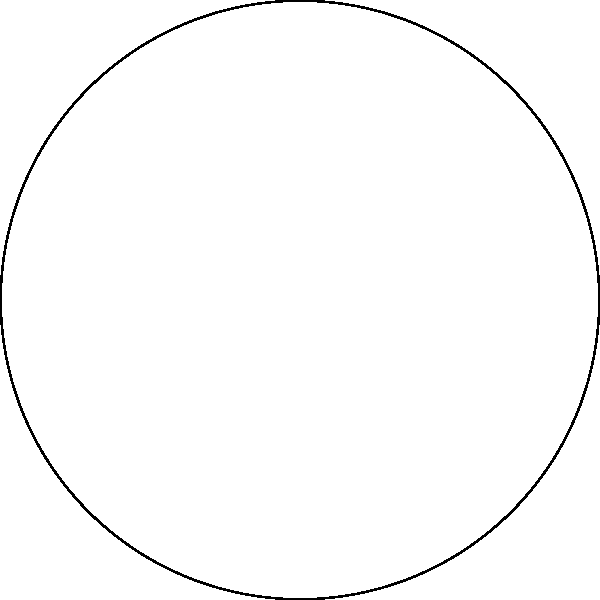In a traditional Hawaiian medicine wheel, eight healing plants are arranged in a circle as shown in the diagram. The plants are labeled P1 through P8. Using the polar coordinate system with the origin at the center of the circle and the positive x-axis as the reference direction, what are the polar coordinates $(r, \theta)$ of plant P3? To find the polar coordinates of plant P3, we need to follow these steps:

1. Identify the position of P3 in the circle:
   P3 is located in the first quadrant, 45° counterclockwise from the positive y-axis.

2. Determine the radius (r):
   The radius is given as 5 units for all plants in the circle.

3. Calculate the angle (θ):
   - There are 8 plants equally spaced around the circle.
   - Each plant is separated by 45° (360° ÷ 8 = 45°).
   - P3 is the third plant counterclockwise from the positive x-axis.
   - Therefore, the angle for P3 is: 3 × 45° = 135°

4. Express the angle in radians:
   $\theta = 135° \times \frac{\pi}{180°} = \frac{3\pi}{4}$ radians

5. Write the polar coordinates:
   The polar coordinates are expressed as $(r, \theta)$.

Therefore, the polar coordinates of plant P3 are $(5, \frac{3\pi}{4})$.
Answer: $(5, \frac{3\pi}{4})$ 